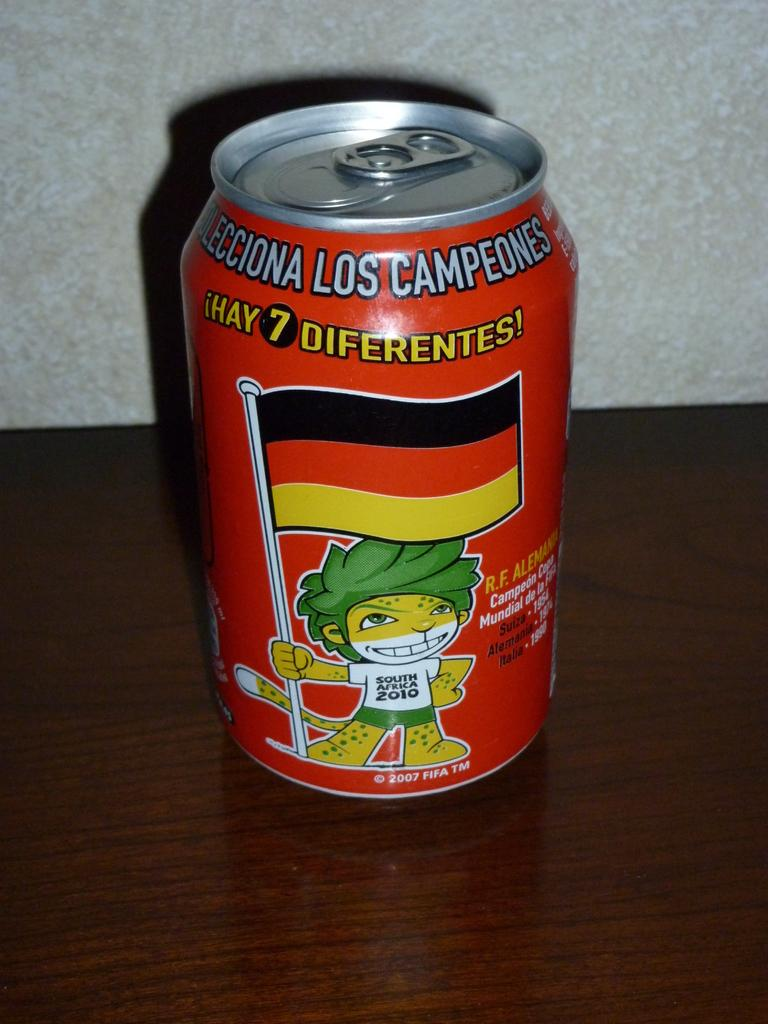Provide a one-sentence caption for the provided image. A canned drink with a graphic of a lion wearing a South Africa 2010 shirt holding a flag on the front. 